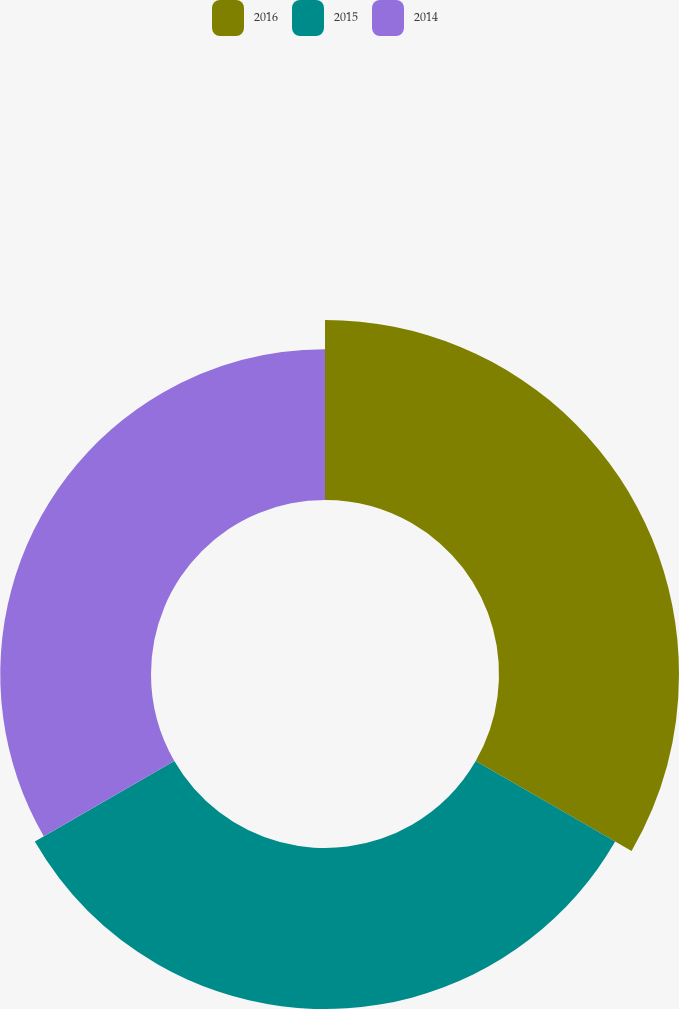<chart> <loc_0><loc_0><loc_500><loc_500><pie_chart><fcel>2016<fcel>2015<fcel>2014<nl><fcel>36.6%<fcel>32.75%<fcel>30.65%<nl></chart> 